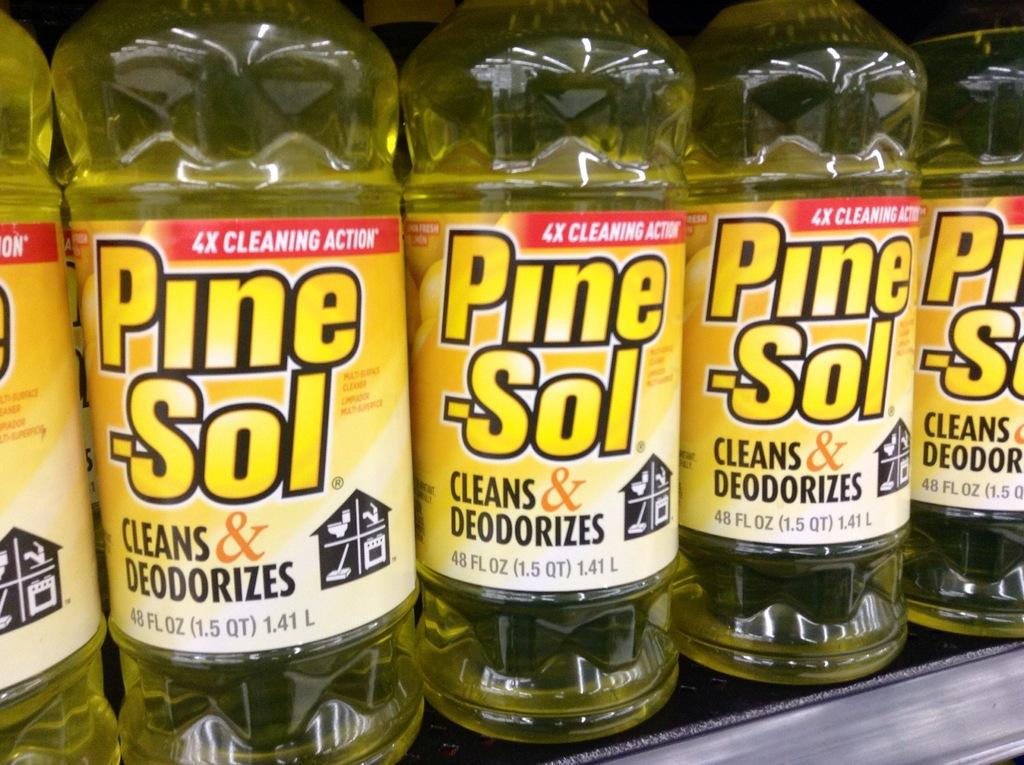<image>
Render a clear and concise summary of the photo. a row of pine-sol cleans & deodorizes bottles 